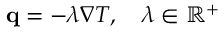Convert formula to latex. <formula><loc_0><loc_0><loc_500><loc_500>\begin{array} { r } { \mathbf q = - \lambda \nabla T , \quad \lambda \in \mathbb { R ^ { + } } } \end{array}</formula> 